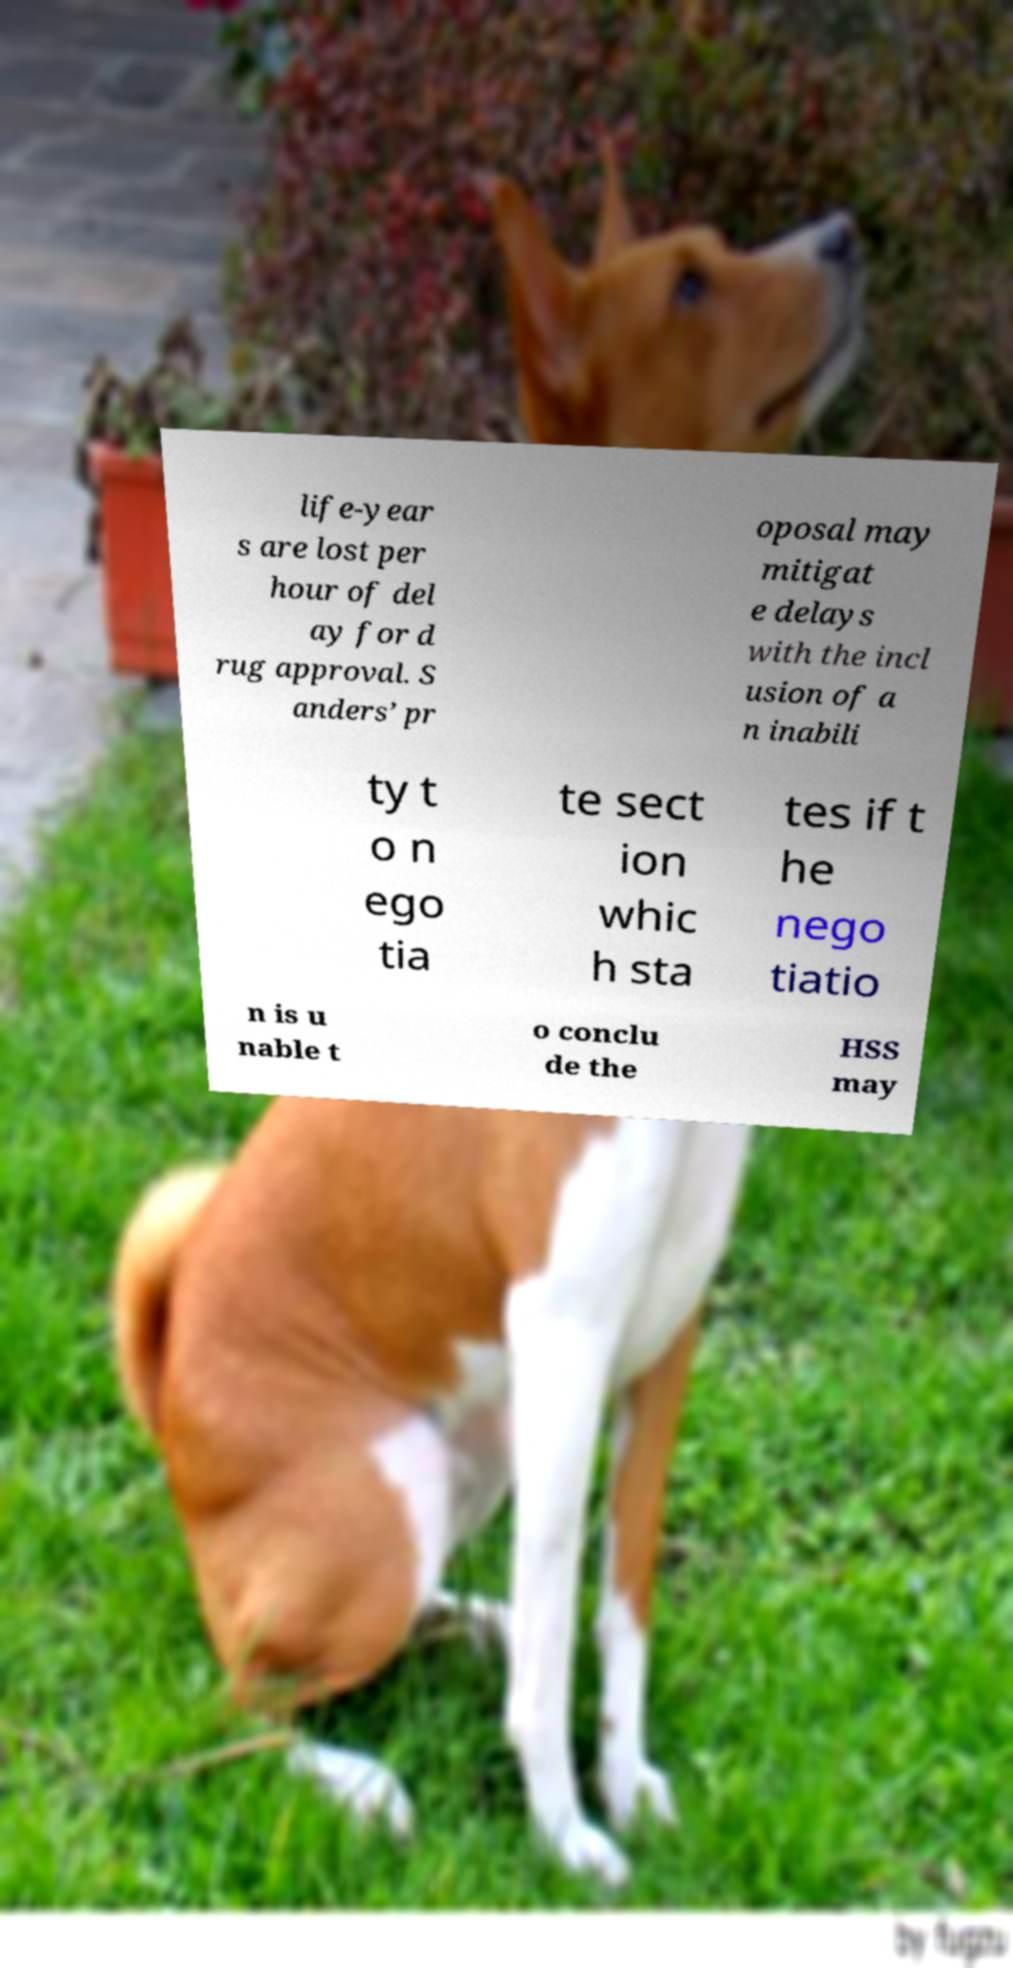I need the written content from this picture converted into text. Can you do that? life-year s are lost per hour of del ay for d rug approval. S anders’ pr oposal may mitigat e delays with the incl usion of a n inabili ty t o n ego tia te sect ion whic h sta tes if t he nego tiatio n is u nable t o conclu de the HSS may 